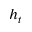Convert formula to latex. <formula><loc_0><loc_0><loc_500><loc_500>h _ { t }</formula> 